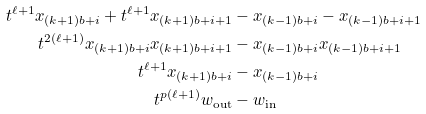Convert formula to latex. <formula><loc_0><loc_0><loc_500><loc_500>t ^ { \ell + 1 } x _ { ( k + 1 ) b + i } + t ^ { \ell + 1 } x _ { ( k + 1 ) b + i + 1 } & - x _ { ( k - 1 ) b + i } - x _ { ( k - 1 ) b + i + 1 } \\ t ^ { 2 ( \ell + 1 ) } x _ { ( k + 1 ) b + i } x _ { ( k + 1 ) b + i + 1 } & - x _ { ( k - 1 ) b + i } x _ { ( k - 1 ) b + i + 1 } \\ t ^ { \ell + 1 } x _ { ( k + 1 ) b + i } & - x _ { ( k - 1 ) b + i } \\ t ^ { p ( \ell + 1 ) } w _ { \text {out} } & - w _ { \text {in} }</formula> 